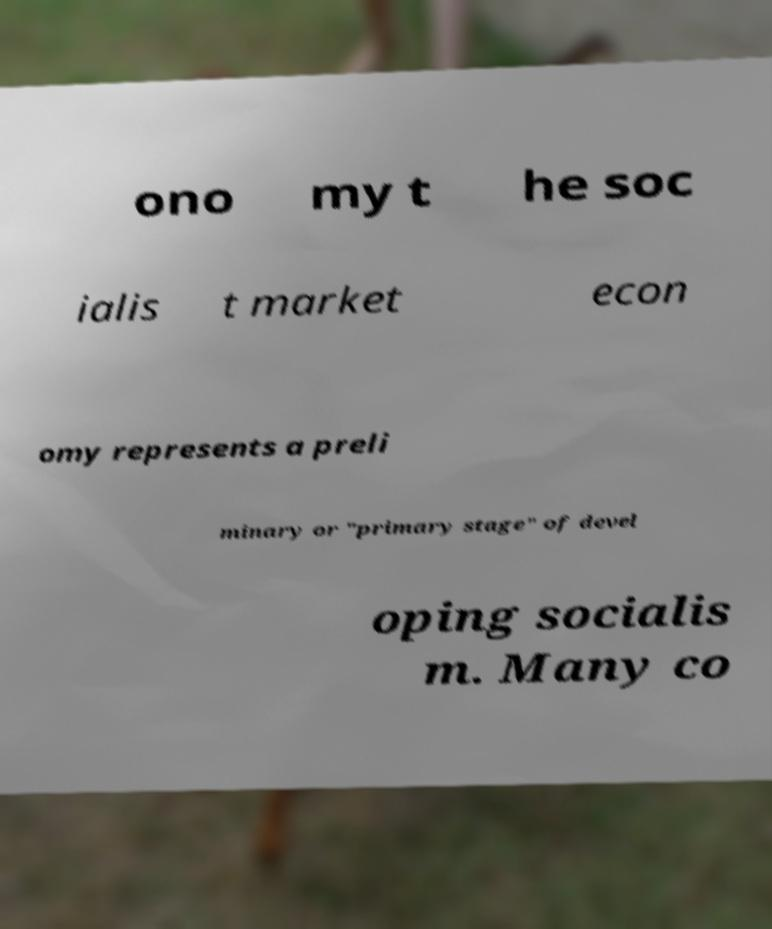Please read and relay the text visible in this image. What does it say? ono my t he soc ialis t market econ omy represents a preli minary or "primary stage" of devel oping socialis m. Many co 